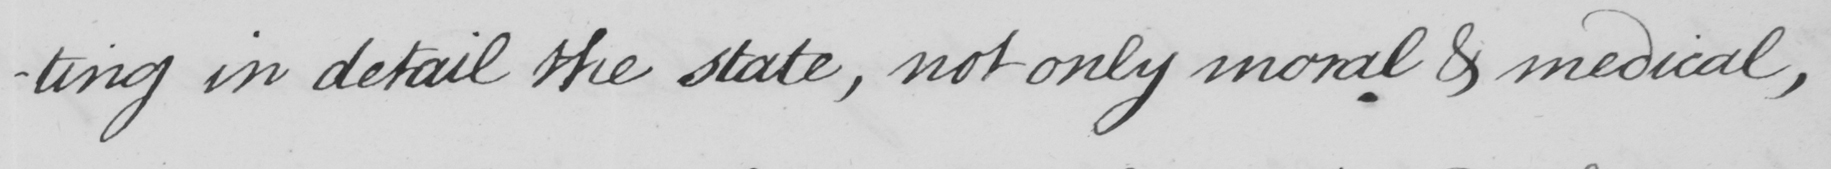Transcribe the text shown in this historical manuscript line. -ting in detail the state , not only moral & medical , 